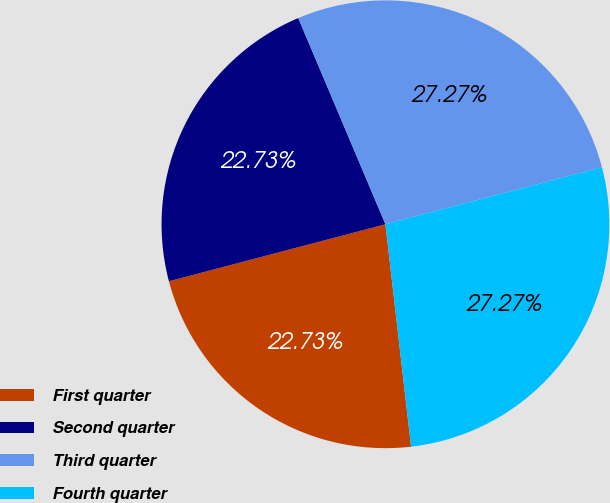<chart> <loc_0><loc_0><loc_500><loc_500><pie_chart><fcel>First quarter<fcel>Second quarter<fcel>Third quarter<fcel>Fourth quarter<nl><fcel>22.73%<fcel>22.73%<fcel>27.27%<fcel>27.27%<nl></chart> 